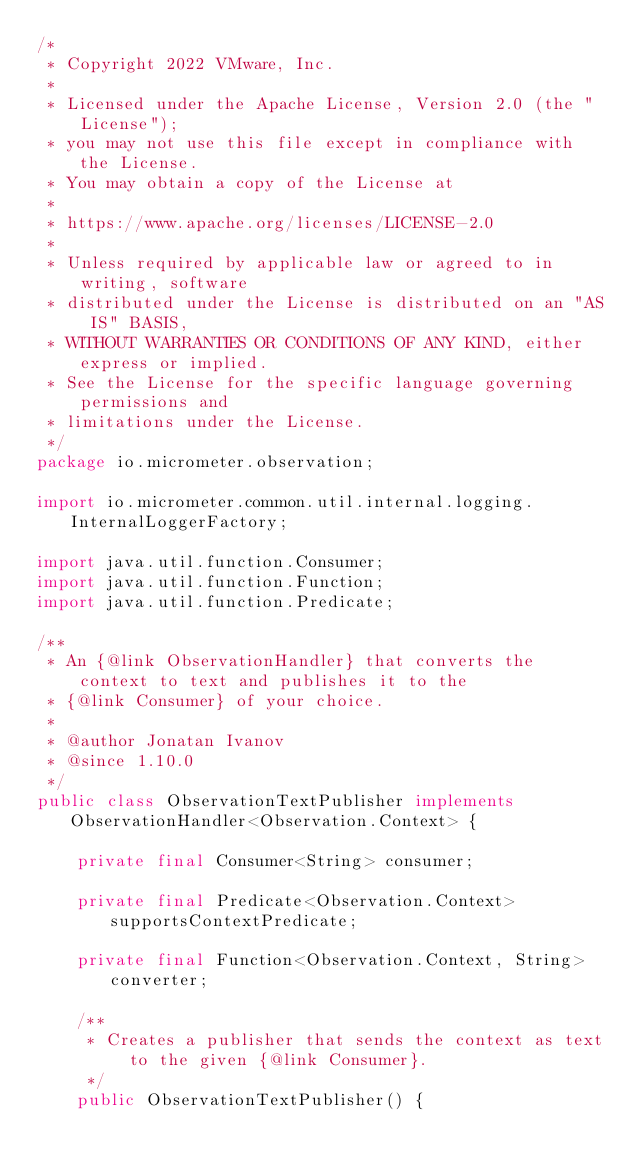Convert code to text. <code><loc_0><loc_0><loc_500><loc_500><_Java_>/*
 * Copyright 2022 VMware, Inc.
 *
 * Licensed under the Apache License, Version 2.0 (the "License");
 * you may not use this file except in compliance with the License.
 * You may obtain a copy of the License at
 *
 * https://www.apache.org/licenses/LICENSE-2.0
 *
 * Unless required by applicable law or agreed to in writing, software
 * distributed under the License is distributed on an "AS IS" BASIS,
 * WITHOUT WARRANTIES OR CONDITIONS OF ANY KIND, either express or implied.
 * See the License for the specific language governing permissions and
 * limitations under the License.
 */
package io.micrometer.observation;

import io.micrometer.common.util.internal.logging.InternalLoggerFactory;

import java.util.function.Consumer;
import java.util.function.Function;
import java.util.function.Predicate;

/**
 * An {@link ObservationHandler} that converts the context to text and publishes it to the
 * {@link Consumer} of your choice.
 *
 * @author Jonatan Ivanov
 * @since 1.10.0
 */
public class ObservationTextPublisher implements ObservationHandler<Observation.Context> {

    private final Consumer<String> consumer;

    private final Predicate<Observation.Context> supportsContextPredicate;

    private final Function<Observation.Context, String> converter;

    /**
     * Creates a publisher that sends the context as text to the given {@link Consumer}.
     */
    public ObservationTextPublisher() {</code> 